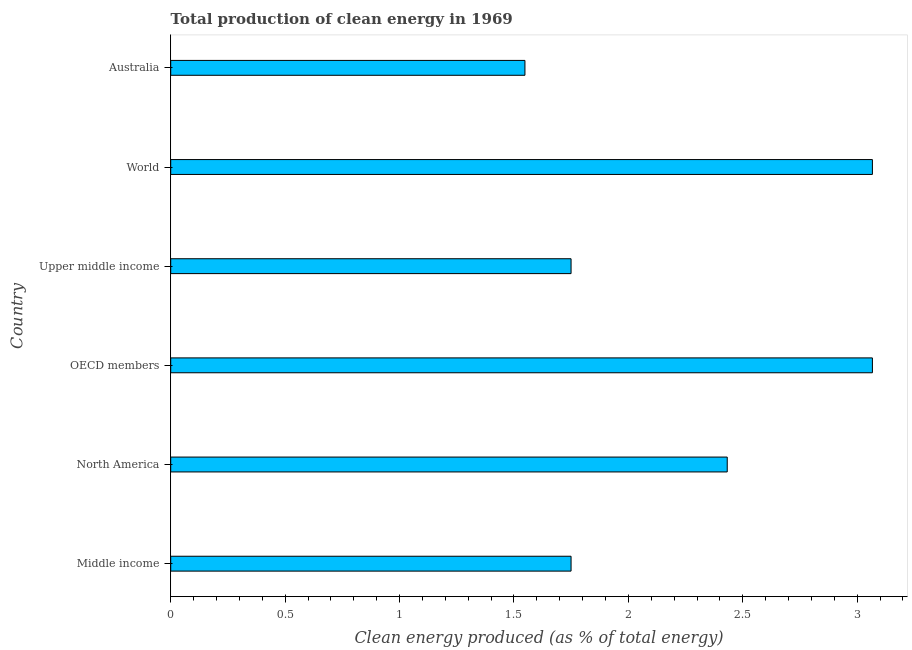What is the title of the graph?
Your response must be concise. Total production of clean energy in 1969. What is the label or title of the X-axis?
Make the answer very short. Clean energy produced (as % of total energy). What is the production of clean energy in North America?
Provide a short and direct response. 2.43. Across all countries, what is the maximum production of clean energy?
Keep it short and to the point. 3.07. Across all countries, what is the minimum production of clean energy?
Your answer should be very brief. 1.55. In which country was the production of clean energy maximum?
Provide a succinct answer. OECD members. In which country was the production of clean energy minimum?
Your response must be concise. Australia. What is the sum of the production of clean energy?
Keep it short and to the point. 13.61. What is the difference between the production of clean energy in Australia and North America?
Provide a succinct answer. -0.88. What is the average production of clean energy per country?
Provide a short and direct response. 2.27. What is the median production of clean energy?
Give a very brief answer. 2.09. What is the ratio of the production of clean energy in Australia to that in Upper middle income?
Your answer should be compact. 0.89. Is the production of clean energy in North America less than that in OECD members?
Your answer should be compact. Yes. Is the difference between the production of clean energy in OECD members and Upper middle income greater than the difference between any two countries?
Your answer should be very brief. No. What is the difference between the highest and the second highest production of clean energy?
Provide a succinct answer. 0. What is the difference between the highest and the lowest production of clean energy?
Make the answer very short. 1.52. In how many countries, is the production of clean energy greater than the average production of clean energy taken over all countries?
Make the answer very short. 3. How many bars are there?
Provide a succinct answer. 6. Are all the bars in the graph horizontal?
Provide a short and direct response. Yes. Are the values on the major ticks of X-axis written in scientific E-notation?
Offer a terse response. No. What is the Clean energy produced (as % of total energy) in Middle income?
Your response must be concise. 1.75. What is the Clean energy produced (as % of total energy) in North America?
Provide a succinct answer. 2.43. What is the Clean energy produced (as % of total energy) in OECD members?
Your answer should be compact. 3.07. What is the Clean energy produced (as % of total energy) of Upper middle income?
Provide a succinct answer. 1.75. What is the Clean energy produced (as % of total energy) in World?
Ensure brevity in your answer.  3.07. What is the Clean energy produced (as % of total energy) of Australia?
Provide a short and direct response. 1.55. What is the difference between the Clean energy produced (as % of total energy) in Middle income and North America?
Offer a very short reply. -0.68. What is the difference between the Clean energy produced (as % of total energy) in Middle income and OECD members?
Provide a succinct answer. -1.32. What is the difference between the Clean energy produced (as % of total energy) in Middle income and World?
Offer a terse response. -1.32. What is the difference between the Clean energy produced (as % of total energy) in Middle income and Australia?
Provide a short and direct response. 0.2. What is the difference between the Clean energy produced (as % of total energy) in North America and OECD members?
Provide a short and direct response. -0.63. What is the difference between the Clean energy produced (as % of total energy) in North America and Upper middle income?
Provide a succinct answer. 0.68. What is the difference between the Clean energy produced (as % of total energy) in North America and World?
Ensure brevity in your answer.  -0.63. What is the difference between the Clean energy produced (as % of total energy) in North America and Australia?
Your answer should be compact. 0.88. What is the difference between the Clean energy produced (as % of total energy) in OECD members and Upper middle income?
Give a very brief answer. 1.32. What is the difference between the Clean energy produced (as % of total energy) in OECD members and World?
Keep it short and to the point. 0. What is the difference between the Clean energy produced (as % of total energy) in OECD members and Australia?
Provide a succinct answer. 1.52. What is the difference between the Clean energy produced (as % of total energy) in Upper middle income and World?
Keep it short and to the point. -1.32. What is the difference between the Clean energy produced (as % of total energy) in Upper middle income and Australia?
Your answer should be very brief. 0.2. What is the difference between the Clean energy produced (as % of total energy) in World and Australia?
Provide a short and direct response. 1.52. What is the ratio of the Clean energy produced (as % of total energy) in Middle income to that in North America?
Offer a very short reply. 0.72. What is the ratio of the Clean energy produced (as % of total energy) in Middle income to that in OECD members?
Make the answer very short. 0.57. What is the ratio of the Clean energy produced (as % of total energy) in Middle income to that in Upper middle income?
Provide a succinct answer. 1. What is the ratio of the Clean energy produced (as % of total energy) in Middle income to that in World?
Keep it short and to the point. 0.57. What is the ratio of the Clean energy produced (as % of total energy) in Middle income to that in Australia?
Provide a short and direct response. 1.13. What is the ratio of the Clean energy produced (as % of total energy) in North America to that in OECD members?
Make the answer very short. 0.79. What is the ratio of the Clean energy produced (as % of total energy) in North America to that in Upper middle income?
Your answer should be compact. 1.39. What is the ratio of the Clean energy produced (as % of total energy) in North America to that in World?
Offer a terse response. 0.79. What is the ratio of the Clean energy produced (as % of total energy) in North America to that in Australia?
Give a very brief answer. 1.57. What is the ratio of the Clean energy produced (as % of total energy) in OECD members to that in Upper middle income?
Your answer should be compact. 1.75. What is the ratio of the Clean energy produced (as % of total energy) in OECD members to that in World?
Provide a succinct answer. 1. What is the ratio of the Clean energy produced (as % of total energy) in OECD members to that in Australia?
Your answer should be compact. 1.98. What is the ratio of the Clean energy produced (as % of total energy) in Upper middle income to that in World?
Give a very brief answer. 0.57. What is the ratio of the Clean energy produced (as % of total energy) in Upper middle income to that in Australia?
Keep it short and to the point. 1.13. What is the ratio of the Clean energy produced (as % of total energy) in World to that in Australia?
Your response must be concise. 1.98. 